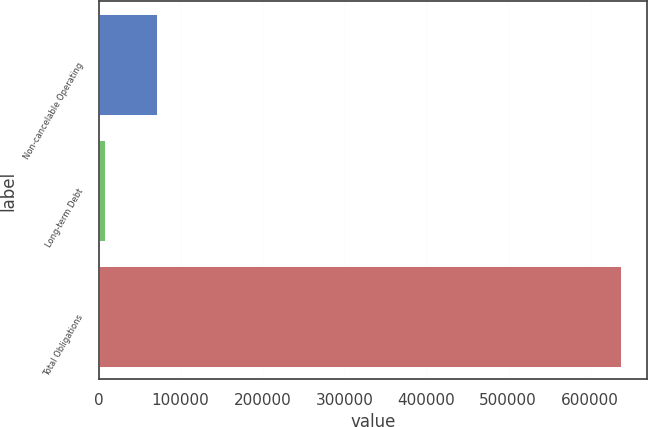<chart> <loc_0><loc_0><loc_500><loc_500><bar_chart><fcel>Non-cancelable Operating<fcel>Long-term Debt<fcel>Total Obligations<nl><fcel>71024.1<fcel>8034<fcel>637935<nl></chart> 